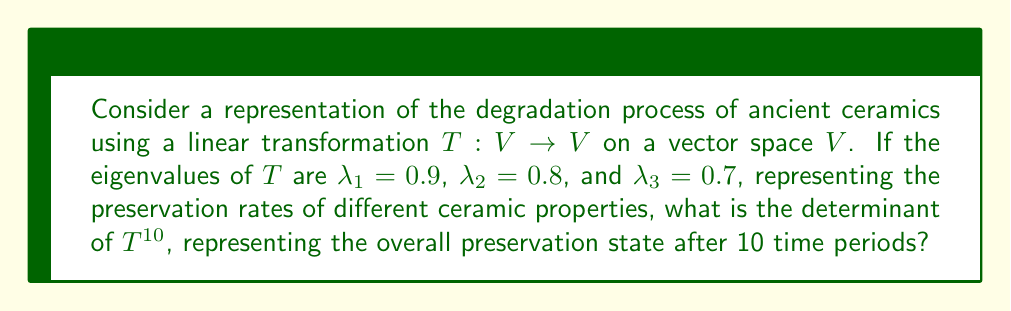What is the answer to this math problem? To solve this problem, we'll follow these steps:

1) In representation theory, linear transformations can be used to model changes in a system over time. Here, $T$ represents the degradation process for one time period.

2) The eigenvalues represent the rates at which different properties of the ceramic are preserved. Values less than 1 indicate degradation.

3) The determinant of a linear transformation is the product of its eigenvalues:

   $\det(T) = \lambda_1 \cdot \lambda_2 \cdot \lambda_3 = 0.9 \cdot 0.8 \cdot 0.7 = 0.504$

4) For $T^{10}$, which represents 10 applications of the transformation (i.e., 10 time periods), the eigenvalues are raised to the 10th power:

   $\det(T^{10}) = \lambda_1^{10} \cdot \lambda_2^{10} \cdot \lambda_3^{10}$

5) Calculate each term:
   $0.9^{10} \approx 0.3487$
   $0.8^{10} \approx 0.1074$
   $0.7^{10} \approx 0.0282$

6) Multiply these results:

   $\det(T^{10}) = 0.3487 \cdot 0.1074 \cdot 0.0282 \approx 0.001054$

This small value indicates significant degradation after 10 time periods.
Answer: $\approx 0.001054$ 